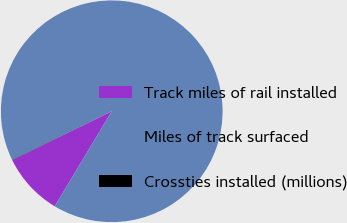Convert chart to OTSL. <chart><loc_0><loc_0><loc_500><loc_500><pie_chart><fcel>Track miles of rail installed<fcel>Miles of track surfaced<fcel>Crossties installed (millions)<nl><fcel>9.12%<fcel>90.84%<fcel>0.04%<nl></chart> 